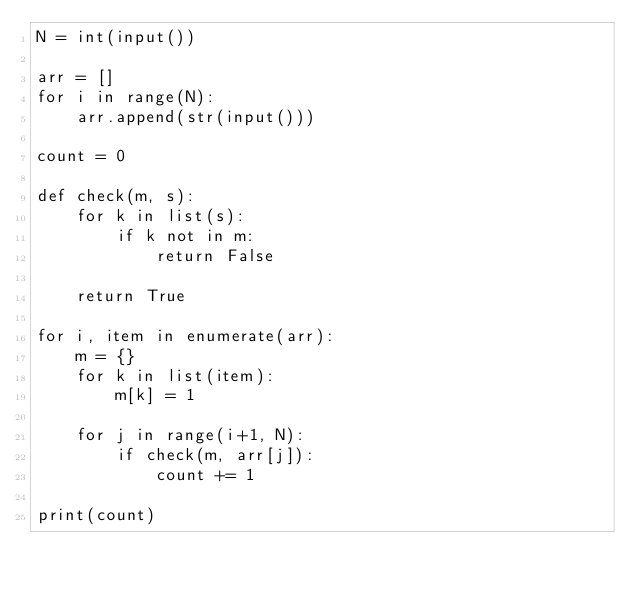<code> <loc_0><loc_0><loc_500><loc_500><_Python_>N = int(input())

arr = []
for i in range(N):
    arr.append(str(input()))

count = 0

def check(m, s):
    for k in list(s):
        if k not in m:
            return False

    return True

for i, item in enumerate(arr):
    m = {}
    for k in list(item):
        m[k] = 1
    
    for j in range(i+1, N):
        if check(m, arr[j]):
            count += 1

print(count)</code> 